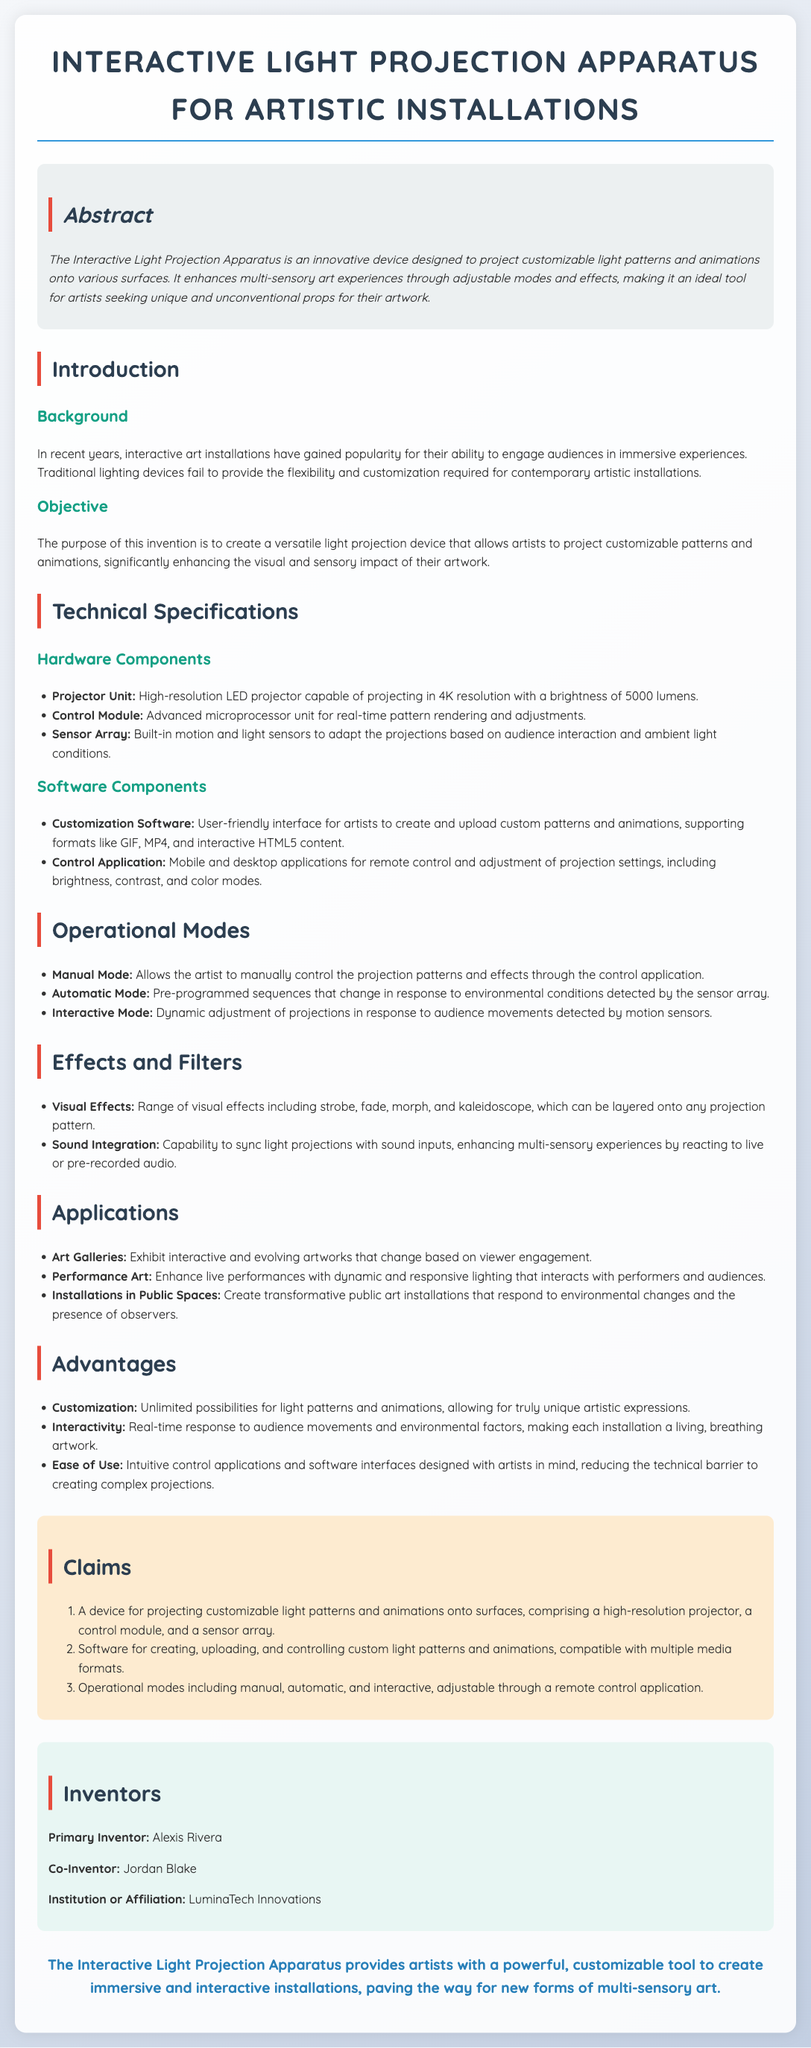What is the brightness of the projector unit? The brightness of the projector unit is specified as 5000 lumens in the document's technical specifications.
Answer: 5000 lumens Who are the inventors of the device? The inventors mentioned in the document are Alexis Rivera and Jordan Blake.
Answer: Alexis Rivera, Jordan Blake What formats does the customization software support? The document lists formats such as GIF, MP4, and interactive HTML5 content supported by the customization software.
Answer: GIF, MP4, HTML5 What are the operational modes available for the apparatus? The document outlines three operational modes: Manual Mode, Automatic Mode, and Interactive Mode.
Answer: Manual, Automatic, Interactive What is one application of the Interactive Light Projection Apparatus? Applications listed in the document include art galleries, performance art, and installations in public spaces.
Answer: Art galleries How does the device enhance multi-sensory experiences? The device enhances multi-sensory experiences through sound integration that syncs light projections with audio inputs.
Answer: Sound integration What is the purpose of the Interactive Light Projection Apparatus? The document states the purpose is to create a versatile light projection device for artists.
Answer: Create a versatile light projection device What is the background context for this invention? The background explains that traditional lighting devices fail to provide the necessary flexibility for contemporary artistic installations.
Answer: Traditional lighting devices fail to provide flexibility 